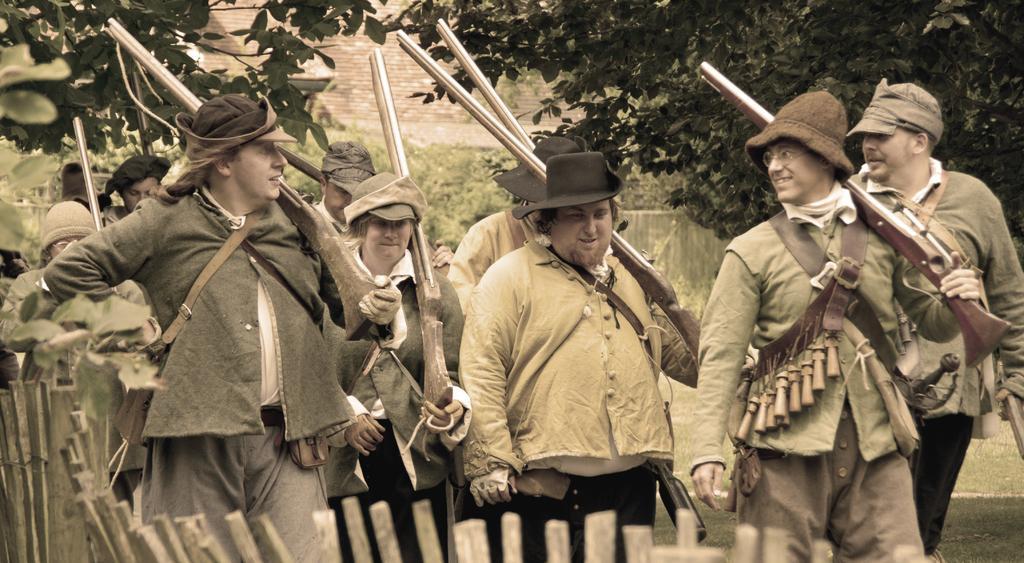Can you describe this image briefly? These people are holding guns. Land is covered with grass. Background there are plants and trees. 